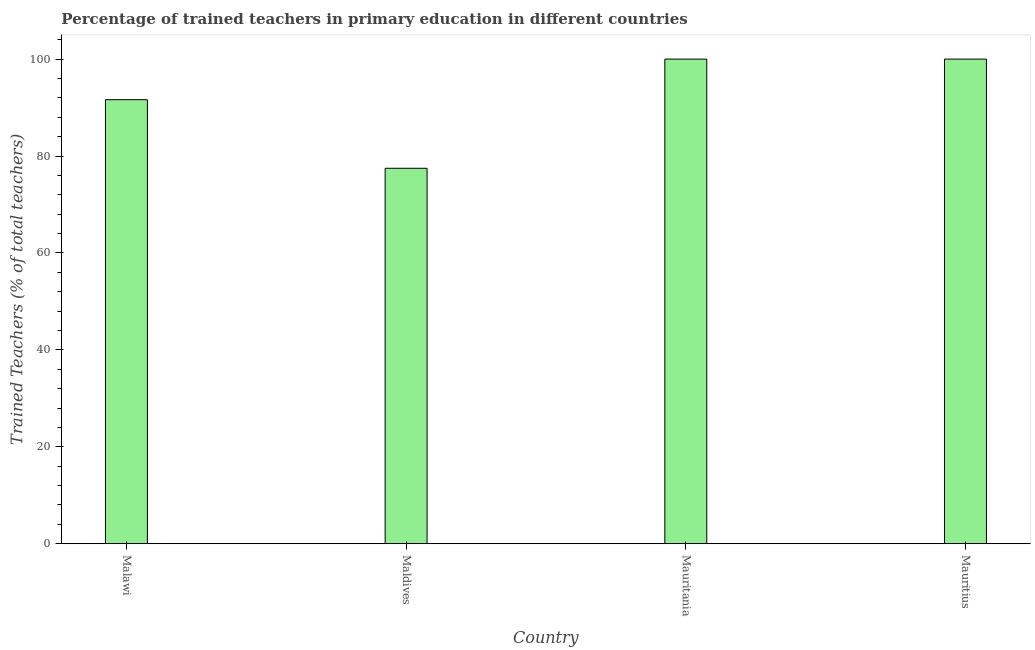Does the graph contain any zero values?
Provide a succinct answer. No. Does the graph contain grids?
Your answer should be compact. No. What is the title of the graph?
Make the answer very short. Percentage of trained teachers in primary education in different countries. What is the label or title of the X-axis?
Keep it short and to the point. Country. What is the label or title of the Y-axis?
Ensure brevity in your answer.  Trained Teachers (% of total teachers). What is the percentage of trained teachers in Maldives?
Keep it short and to the point. 77.47. Across all countries, what is the minimum percentage of trained teachers?
Offer a very short reply. 77.47. In which country was the percentage of trained teachers maximum?
Ensure brevity in your answer.  Mauritania. In which country was the percentage of trained teachers minimum?
Your answer should be compact. Maldives. What is the sum of the percentage of trained teachers?
Offer a terse response. 369.1. What is the difference between the percentage of trained teachers in Malawi and Mauritania?
Your answer should be compact. -8.37. What is the average percentage of trained teachers per country?
Your answer should be very brief. 92.28. What is the median percentage of trained teachers?
Your answer should be very brief. 95.81. In how many countries, is the percentage of trained teachers greater than 36 %?
Offer a very short reply. 4. What is the ratio of the percentage of trained teachers in Malawi to that in Mauritania?
Ensure brevity in your answer.  0.92. Is the difference between the percentage of trained teachers in Maldives and Mauritania greater than the difference between any two countries?
Offer a very short reply. Yes. What is the difference between the highest and the second highest percentage of trained teachers?
Ensure brevity in your answer.  0. What is the difference between the highest and the lowest percentage of trained teachers?
Offer a very short reply. 22.53. In how many countries, is the percentage of trained teachers greater than the average percentage of trained teachers taken over all countries?
Offer a very short reply. 2. Are all the bars in the graph horizontal?
Make the answer very short. No. How many countries are there in the graph?
Ensure brevity in your answer.  4. What is the difference between two consecutive major ticks on the Y-axis?
Your answer should be very brief. 20. What is the Trained Teachers (% of total teachers) in Malawi?
Ensure brevity in your answer.  91.63. What is the Trained Teachers (% of total teachers) of Maldives?
Offer a terse response. 77.47. What is the Trained Teachers (% of total teachers) in Mauritania?
Provide a succinct answer. 100. What is the difference between the Trained Teachers (% of total teachers) in Malawi and Maldives?
Give a very brief answer. 14.15. What is the difference between the Trained Teachers (% of total teachers) in Malawi and Mauritania?
Keep it short and to the point. -8.37. What is the difference between the Trained Teachers (% of total teachers) in Malawi and Mauritius?
Make the answer very short. -8.37. What is the difference between the Trained Teachers (% of total teachers) in Maldives and Mauritania?
Keep it short and to the point. -22.53. What is the difference between the Trained Teachers (% of total teachers) in Maldives and Mauritius?
Provide a succinct answer. -22.53. What is the difference between the Trained Teachers (% of total teachers) in Mauritania and Mauritius?
Offer a very short reply. 0. What is the ratio of the Trained Teachers (% of total teachers) in Malawi to that in Maldives?
Your response must be concise. 1.18. What is the ratio of the Trained Teachers (% of total teachers) in Malawi to that in Mauritania?
Give a very brief answer. 0.92. What is the ratio of the Trained Teachers (% of total teachers) in Malawi to that in Mauritius?
Provide a succinct answer. 0.92. What is the ratio of the Trained Teachers (% of total teachers) in Maldives to that in Mauritania?
Your answer should be compact. 0.78. What is the ratio of the Trained Teachers (% of total teachers) in Maldives to that in Mauritius?
Provide a succinct answer. 0.78. 